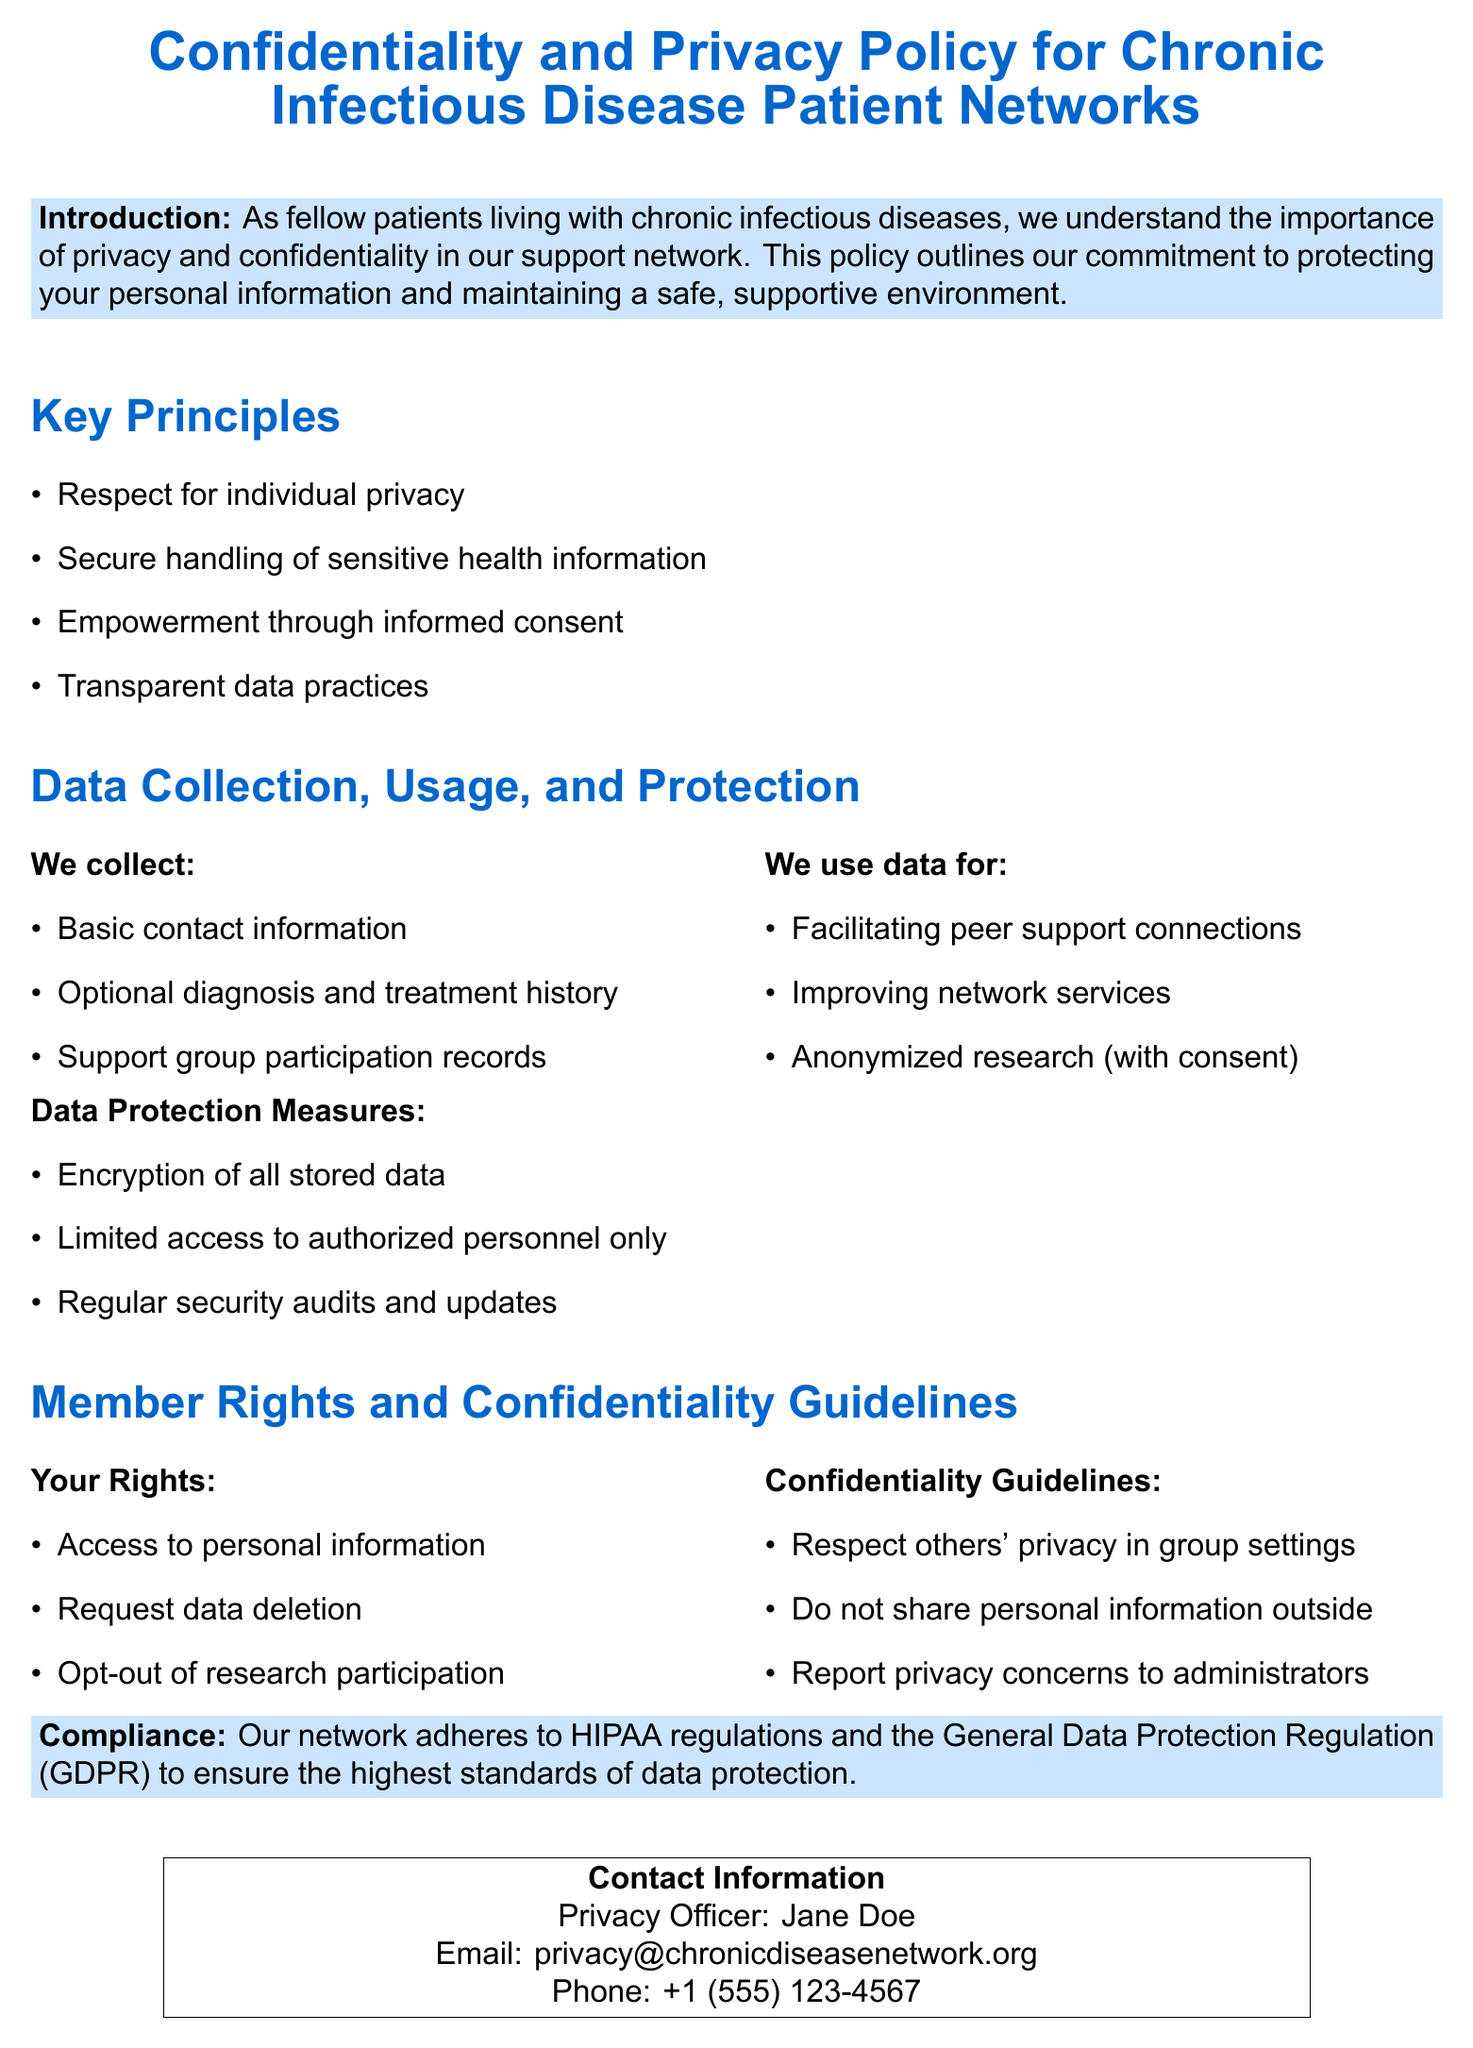What is the title of the document? The title is mentioned at the beginning and outlines the main focus of the policy document.
Answer: Confidentiality and Privacy Policy for Chronic Infectious Disease Patient Networks Who is the Privacy Officer? The Privacy Officer's name is specified in the contact information section of the document.
Answer: Jane Doe What are the four key principles mentioned? The key principles of the policy are outlined in the corresponding section.
Answer: Respect for individual privacy, Secure handling of sensitive health information, Empowerment through informed consent, Transparent data practices What type of data do we collect? The document specifies the types of data that are collected, listed under data collection.
Answer: Basic contact information, Optional diagnosis and treatment history, Support group participation records How can members request data deletion? The rights of members regarding their personal information are outlined, including the ability to request deletion.
Answer: By requesting through established processes in the policy What regulations does the network comply with? The compliance section mentions specific regulations that govern data protection within the network.
Answer: HIPAA and GDPR What is one of the confidentiality guidelines for members? Confidentiality guidelines are listed to ensure respect and privacy among members.
Answer: Respect others' privacy in group settings What security measure is implemented for data protection? The document outlines various measures taken to ensure data protection.
Answer: Encryption of all stored data 